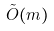Convert formula to latex. <formula><loc_0><loc_0><loc_500><loc_500>\tilde { O } ( m )</formula> 